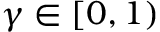Convert formula to latex. <formula><loc_0><loc_0><loc_500><loc_500>\gamma \in [ 0 , 1 )</formula> 